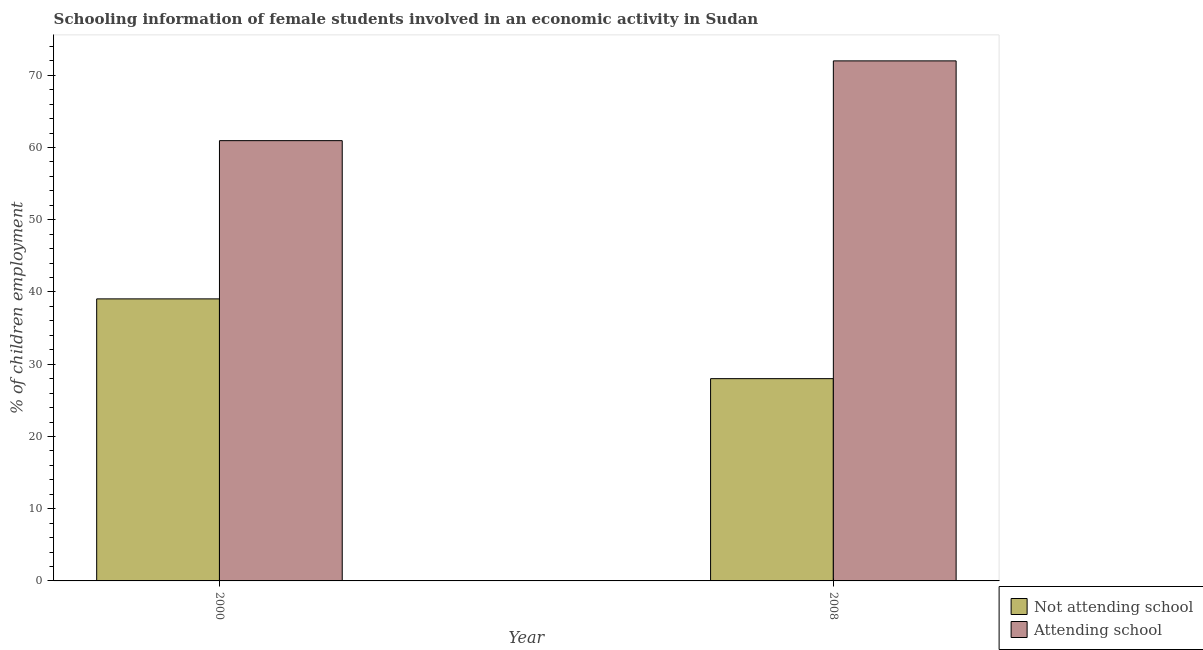How many different coloured bars are there?
Provide a short and direct response. 2. Are the number of bars on each tick of the X-axis equal?
Your response must be concise. Yes. What is the label of the 1st group of bars from the left?
Your answer should be very brief. 2000. In how many cases, is the number of bars for a given year not equal to the number of legend labels?
Provide a short and direct response. 0. What is the percentage of employed females who are not attending school in 2000?
Offer a terse response. 39.05. Across all years, what is the maximum percentage of employed females who are not attending school?
Provide a short and direct response. 39.05. Across all years, what is the minimum percentage of employed females who are not attending school?
Ensure brevity in your answer.  28. In which year was the percentage of employed females who are not attending school maximum?
Ensure brevity in your answer.  2000. What is the total percentage of employed females who are attending school in the graph?
Offer a very short reply. 132.95. What is the difference between the percentage of employed females who are attending school in 2000 and that in 2008?
Offer a very short reply. -11.04. What is the difference between the percentage of employed females who are not attending school in 2008 and the percentage of employed females who are attending school in 2000?
Your answer should be very brief. -11.04. What is the average percentage of employed females who are attending school per year?
Offer a terse response. 66.48. In the year 2000, what is the difference between the percentage of employed females who are attending school and percentage of employed females who are not attending school?
Your answer should be compact. 0. What is the ratio of the percentage of employed females who are attending school in 2000 to that in 2008?
Provide a short and direct response. 0.85. In how many years, is the percentage of employed females who are not attending school greater than the average percentage of employed females who are not attending school taken over all years?
Your response must be concise. 1. What does the 2nd bar from the left in 2008 represents?
Make the answer very short. Attending school. What does the 1st bar from the right in 2000 represents?
Make the answer very short. Attending school. Are all the bars in the graph horizontal?
Your answer should be compact. No. What is the difference between two consecutive major ticks on the Y-axis?
Your answer should be compact. 10. Does the graph contain any zero values?
Offer a terse response. No. Where does the legend appear in the graph?
Your answer should be compact. Bottom right. How many legend labels are there?
Your answer should be compact. 2. What is the title of the graph?
Make the answer very short. Schooling information of female students involved in an economic activity in Sudan. Does "Current education expenditure" appear as one of the legend labels in the graph?
Make the answer very short. No. What is the label or title of the Y-axis?
Keep it short and to the point. % of children employment. What is the % of children employment of Not attending school in 2000?
Provide a succinct answer. 39.05. What is the % of children employment in Attending school in 2000?
Offer a terse response. 60.95. What is the % of children employment of Not attending school in 2008?
Give a very brief answer. 28. What is the % of children employment in Attending school in 2008?
Provide a short and direct response. 72. Across all years, what is the maximum % of children employment in Not attending school?
Offer a very short reply. 39.05. Across all years, what is the maximum % of children employment in Attending school?
Your answer should be compact. 72. Across all years, what is the minimum % of children employment of Not attending school?
Offer a terse response. 28. Across all years, what is the minimum % of children employment in Attending school?
Provide a short and direct response. 60.95. What is the total % of children employment of Not attending school in the graph?
Provide a short and direct response. 67.05. What is the total % of children employment in Attending school in the graph?
Offer a terse response. 132.95. What is the difference between the % of children employment in Not attending school in 2000 and that in 2008?
Provide a short and direct response. 11.04. What is the difference between the % of children employment of Attending school in 2000 and that in 2008?
Keep it short and to the point. -11.04. What is the difference between the % of children employment of Not attending school in 2000 and the % of children employment of Attending school in 2008?
Provide a succinct answer. -32.95. What is the average % of children employment of Not attending school per year?
Ensure brevity in your answer.  33.52. What is the average % of children employment of Attending school per year?
Make the answer very short. 66.48. In the year 2000, what is the difference between the % of children employment of Not attending school and % of children employment of Attending school?
Your answer should be compact. -21.91. In the year 2008, what is the difference between the % of children employment in Not attending school and % of children employment in Attending school?
Ensure brevity in your answer.  -43.99. What is the ratio of the % of children employment in Not attending school in 2000 to that in 2008?
Ensure brevity in your answer.  1.39. What is the ratio of the % of children employment in Attending school in 2000 to that in 2008?
Your answer should be very brief. 0.85. What is the difference between the highest and the second highest % of children employment of Not attending school?
Your answer should be very brief. 11.04. What is the difference between the highest and the second highest % of children employment in Attending school?
Make the answer very short. 11.04. What is the difference between the highest and the lowest % of children employment of Not attending school?
Your answer should be very brief. 11.04. What is the difference between the highest and the lowest % of children employment of Attending school?
Your answer should be compact. 11.04. 